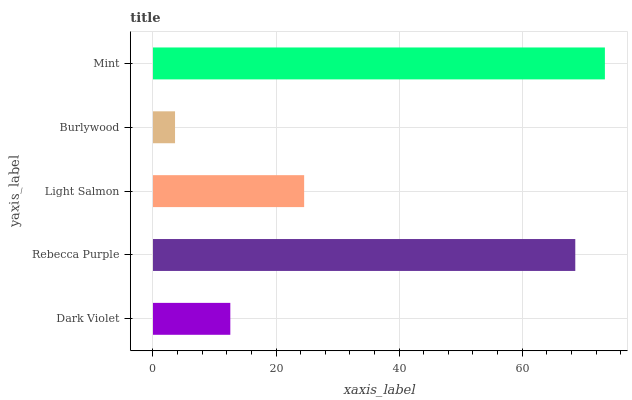Is Burlywood the minimum?
Answer yes or no. Yes. Is Mint the maximum?
Answer yes or no. Yes. Is Rebecca Purple the minimum?
Answer yes or no. No. Is Rebecca Purple the maximum?
Answer yes or no. No. Is Rebecca Purple greater than Dark Violet?
Answer yes or no. Yes. Is Dark Violet less than Rebecca Purple?
Answer yes or no. Yes. Is Dark Violet greater than Rebecca Purple?
Answer yes or no. No. Is Rebecca Purple less than Dark Violet?
Answer yes or no. No. Is Light Salmon the high median?
Answer yes or no. Yes. Is Light Salmon the low median?
Answer yes or no. Yes. Is Dark Violet the high median?
Answer yes or no. No. Is Rebecca Purple the low median?
Answer yes or no. No. 